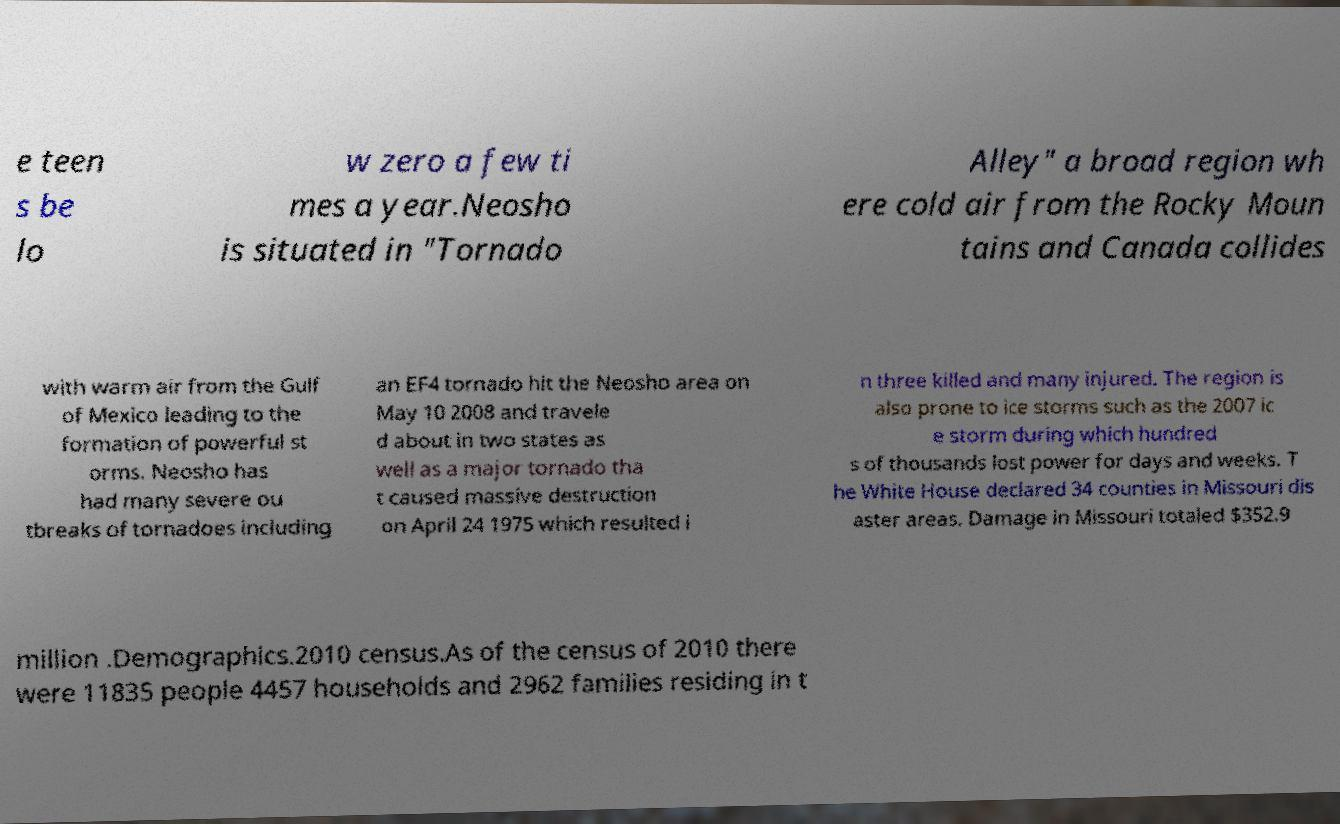For documentation purposes, I need the text within this image transcribed. Could you provide that? e teen s be lo w zero a few ti mes a year.Neosho is situated in "Tornado Alley" a broad region wh ere cold air from the Rocky Moun tains and Canada collides with warm air from the Gulf of Mexico leading to the formation of powerful st orms. Neosho has had many severe ou tbreaks of tornadoes including an EF4 tornado hit the Neosho area on May 10 2008 and travele d about in two states as well as a major tornado tha t caused massive destruction on April 24 1975 which resulted i n three killed and many injured. The region is also prone to ice storms such as the 2007 ic e storm during which hundred s of thousands lost power for days and weeks. T he White House declared 34 counties in Missouri dis aster areas. Damage in Missouri totaled $352.9 million .Demographics.2010 census.As of the census of 2010 there were 11835 people 4457 households and 2962 families residing in t 